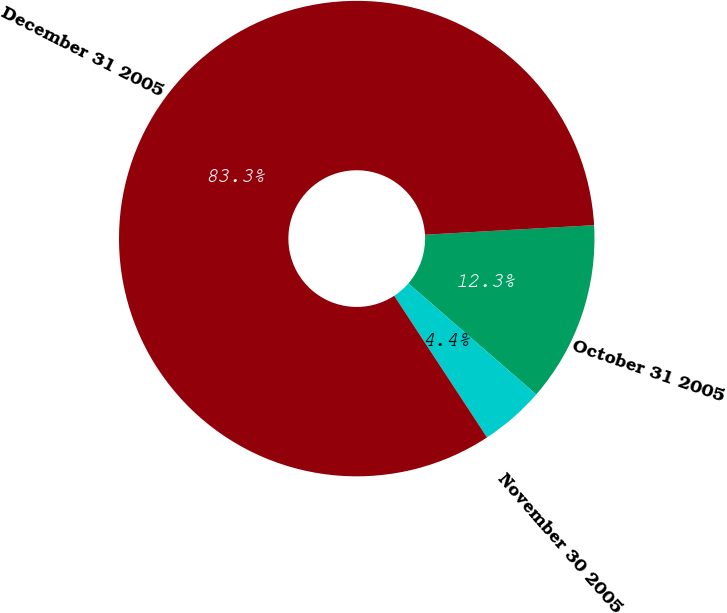<chart> <loc_0><loc_0><loc_500><loc_500><pie_chart><fcel>October 31 2005<fcel>November 30 2005<fcel>December 31 2005<nl><fcel>12.28%<fcel>4.39%<fcel>83.33%<nl></chart> 